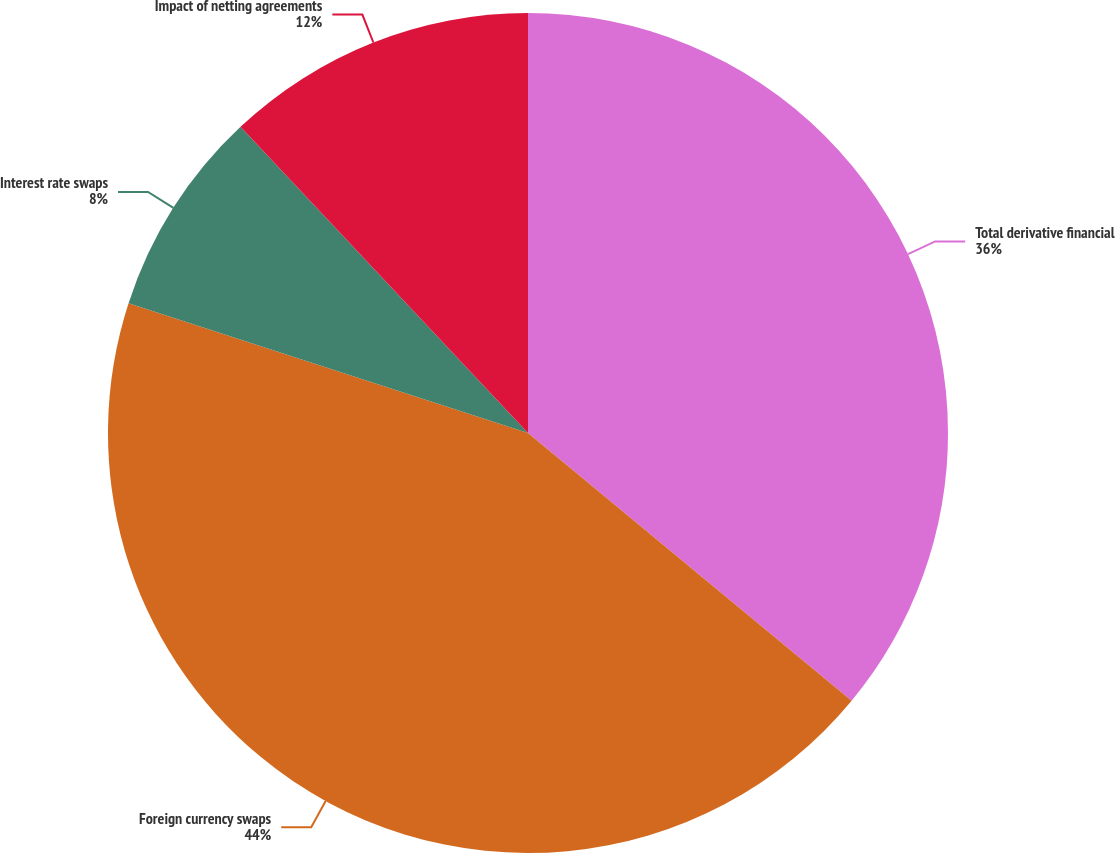Convert chart. <chart><loc_0><loc_0><loc_500><loc_500><pie_chart><fcel>Total derivative financial<fcel>Foreign currency swaps<fcel>Interest rate swaps<fcel>Impact of netting agreements<nl><fcel>36.0%<fcel>44.0%<fcel>8.0%<fcel>12.0%<nl></chart> 